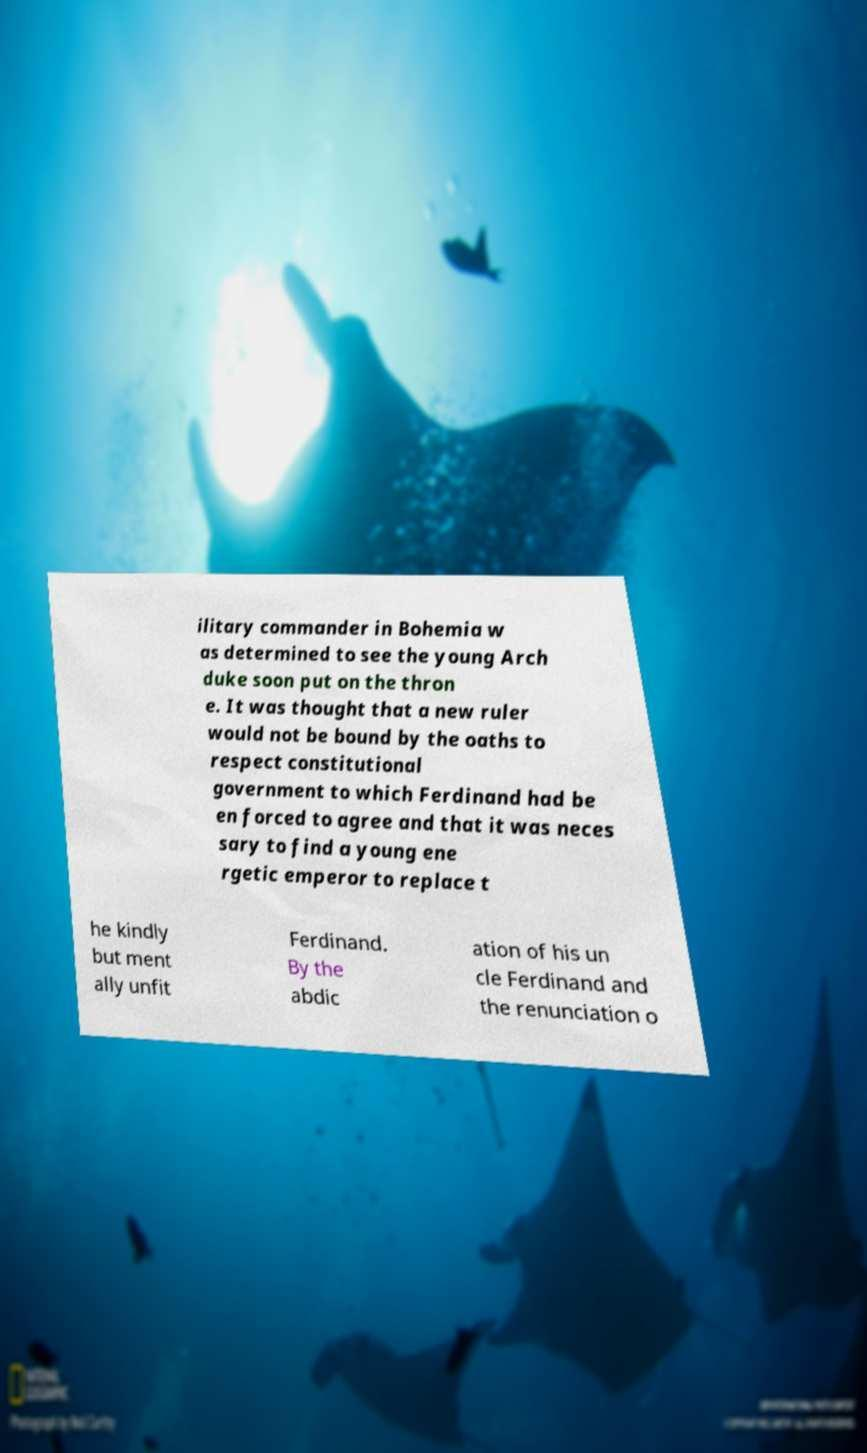Please identify and transcribe the text found in this image. ilitary commander in Bohemia w as determined to see the young Arch duke soon put on the thron e. It was thought that a new ruler would not be bound by the oaths to respect constitutional government to which Ferdinand had be en forced to agree and that it was neces sary to find a young ene rgetic emperor to replace t he kindly but ment ally unfit Ferdinand. By the abdic ation of his un cle Ferdinand and the renunciation o 